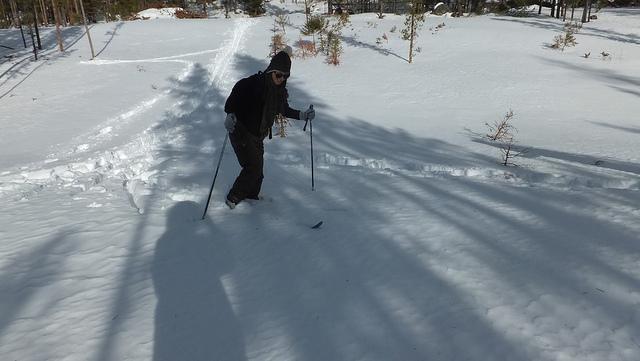What sporting activity is this person doing?
Write a very short answer. Skiing. What is the man wearing on his head?
Give a very brief answer. Hat. Are the skis too buried in the snow for the skier to move forward?
Concise answer only. Yes. What is the person holding in each hand?
Give a very brief answer. Ski poles. What sport is this person doing?
Answer briefly. Skiing. What color are the two stakes in the snow?
Short answer required. Black. 